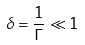Convert formula to latex. <formula><loc_0><loc_0><loc_500><loc_500>\delta = \frac { 1 } { \Gamma } \ll 1</formula> 